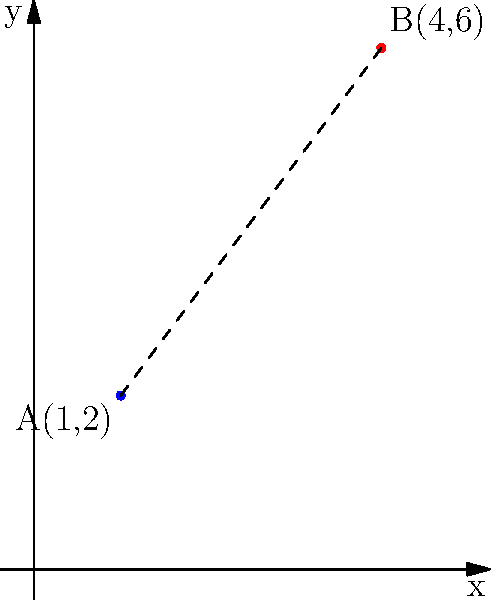In a community outreach program, two support centers are located at points A(1,2) and B(4,6) on a coordinate grid. Each unit represents 1 kilometer. Calculate the straight-line distance between these two centers to determine the area of coverage for mobile services. To find the distance between two points, we can use the distance formula:

$d = \sqrt{(x_2 - x_1)^2 + (y_2 - y_1)^2}$

Where $(x_1, y_1)$ are the coordinates of point A, and $(x_2, y_2)$ are the coordinates of point B.

Step 1: Identify the coordinates
Point A: $(1, 2)$
Point B: $(4, 6)$

Step 2: Substitute the values into the formula
$d = \sqrt{(4 - 1)^2 + (6 - 2)^2}$

Step 3: Calculate the differences
$d = \sqrt{3^2 + 4^2}$

Step 4: Square the differences
$d = \sqrt{9 + 16}$

Step 5: Add the squared differences
$d = \sqrt{25}$

Step 6: Calculate the square root
$d = 5$

Therefore, the distance between the two support centers is 5 kilometers.
Answer: 5 km 